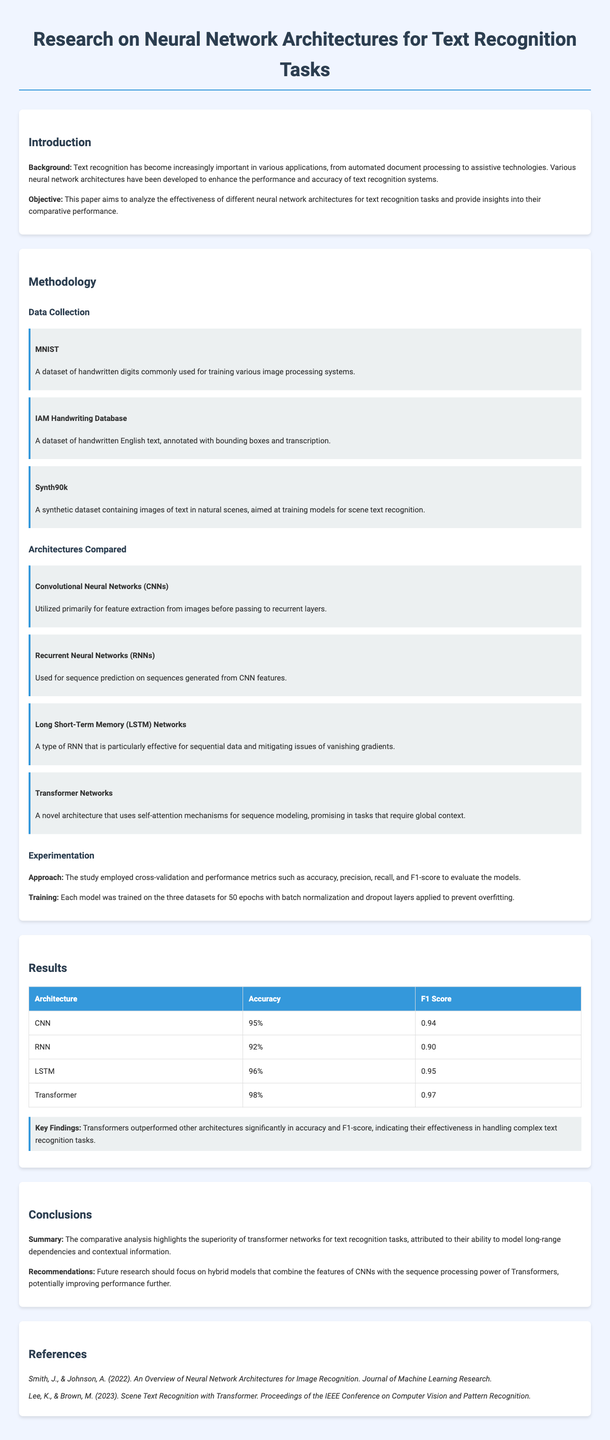What is the objective of the research? The objective of the research is to analyze the effectiveness of different neural network architectures for text recognition tasks.
Answer: Analyze the effectiveness of different neural network architectures for text recognition tasks How many epochs were the models trained for? The models were trained for a consistent number of epochs during the experimentation phase, which is specified in the methodology.
Answer: 50 epochs Which architecture achieved the highest accuracy? The architecture with the highest accuracy is the one with the specified performance metrics in the results section.
Answer: Transformer What datasets were used for data collection? The document lists several datasets used for data collection that aid in training models for text recognition.
Answer: MNIST, IAM Handwriting Database, Synth90k What is the F1 Score of the LSTM architecture? The F1 Score is a specific metric provided for the LSTM architecture in the results section.
Answer: 0.95 Which architecture outperformed all others according to the key findings? The key findings clearly state the architecture that outperformed all others in accuracy and F1-score.
Answer: Transformers What type of networks were primarily used for feature extraction? The document specifies a type of neural network architecture primarily used for feature extraction, mentioned under architectures compared.
Answer: Convolutional Neural Networks What future research direction is recommended? The conclusions section mentions a specific recommendation for future research that involves model combinations.
Answer: Hybrid models combining CNNs with Transformers 